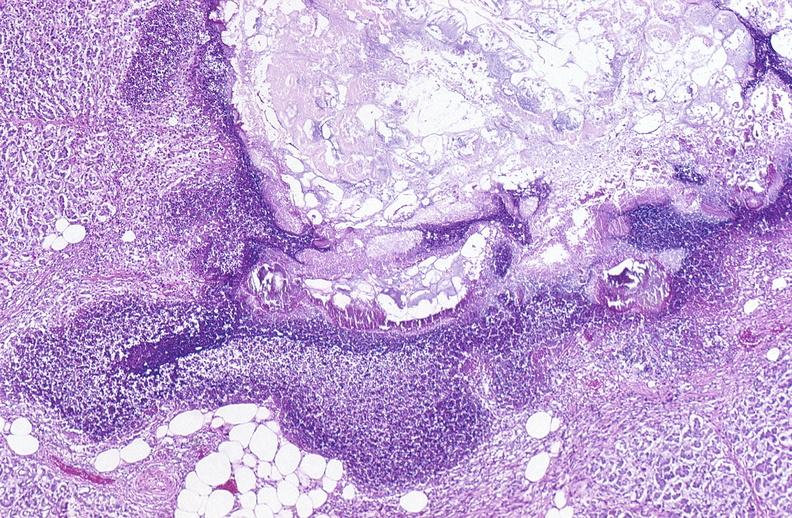what does this image show?
Answer the question using a single word or phrase. Pancreatic fat necrosis 